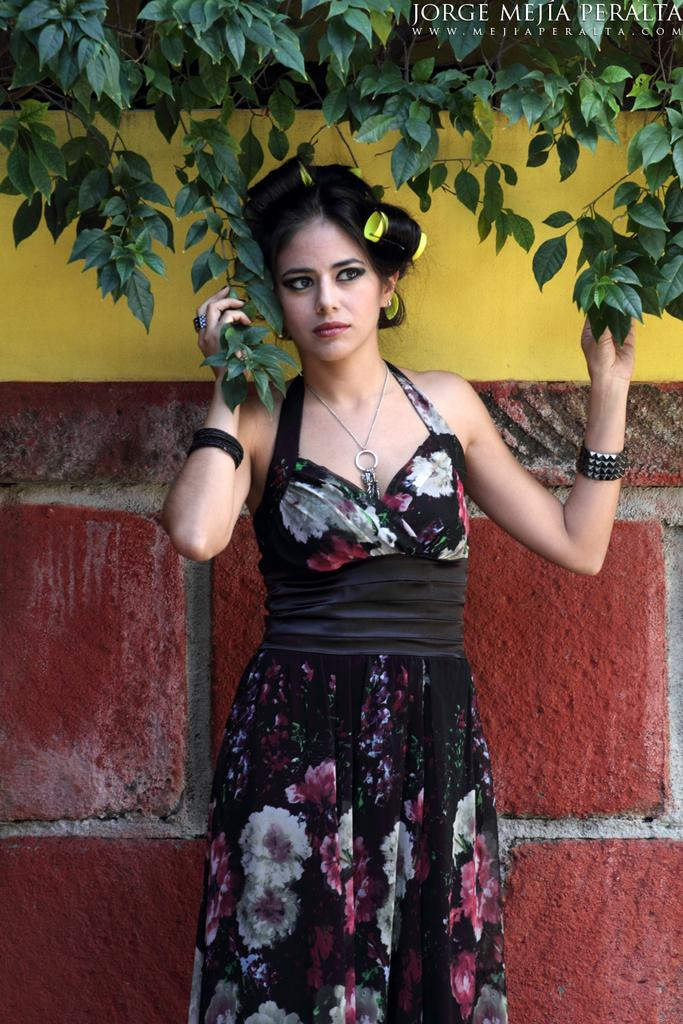What is the main subject in the image? There is a woman standing in the image. What can be seen in the background of the image? There is a wall and leaves of a tree visible in the background. Where is the text located in the image? The text is at the top right corner of the image. What is the woman's desire in the image? There is no indication of the woman's desire in the image, as it does not provide any information about her thoughts or emotions. 